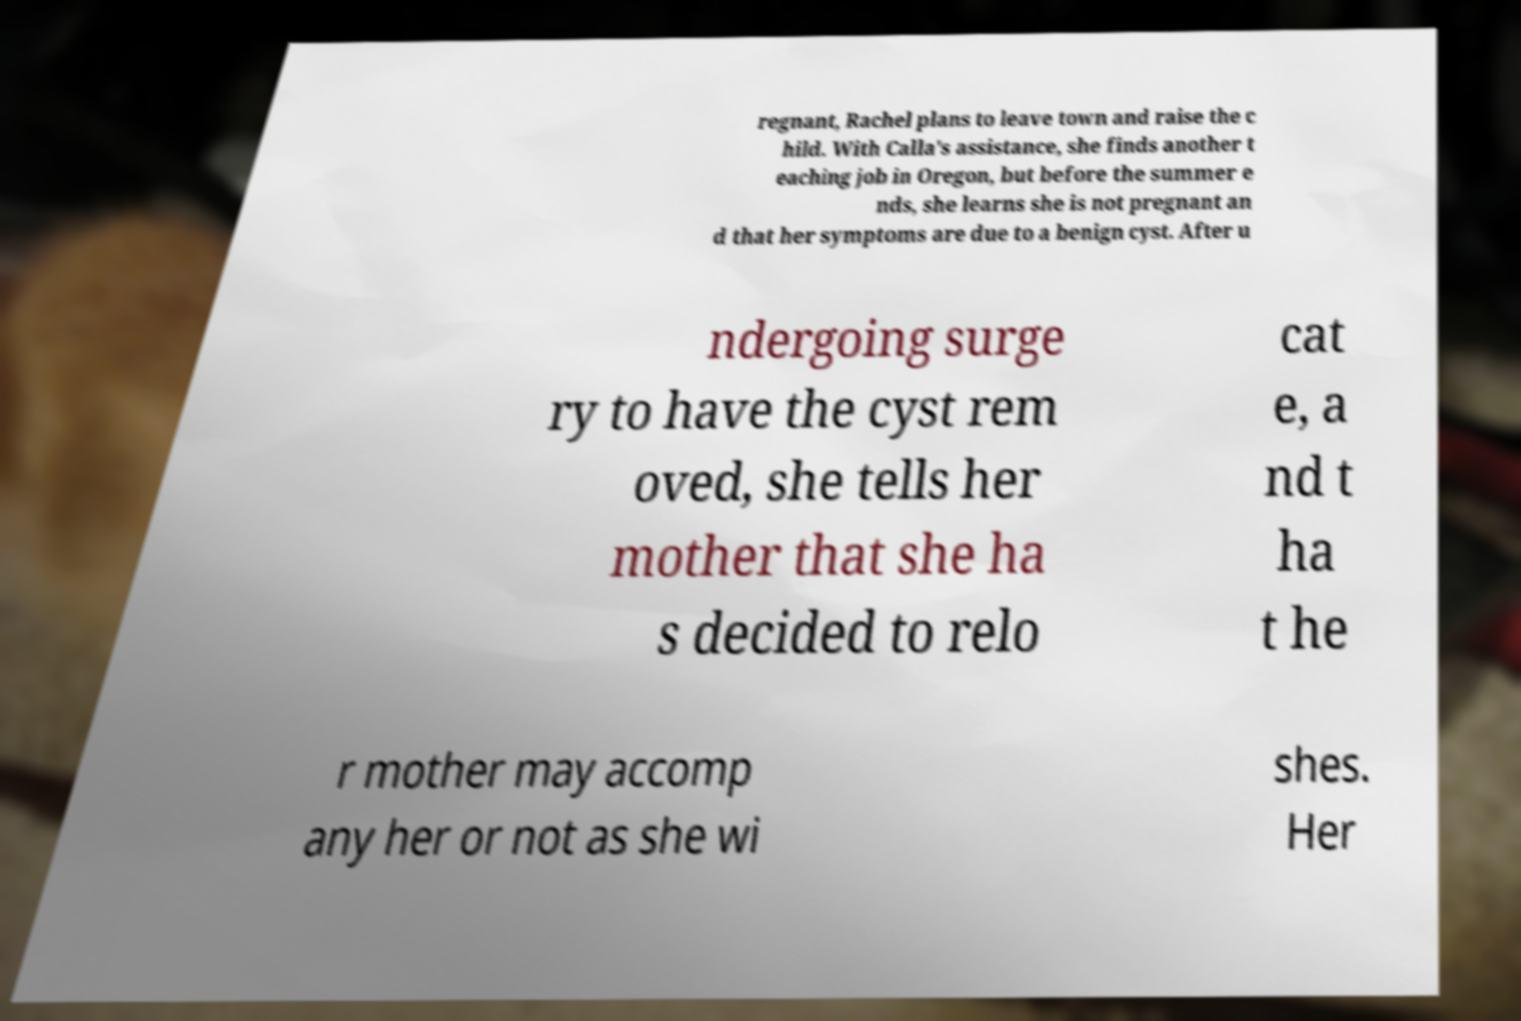For documentation purposes, I need the text within this image transcribed. Could you provide that? regnant, Rachel plans to leave town and raise the c hild. With Calla's assistance, she finds another t eaching job in Oregon, but before the summer e nds, she learns she is not pregnant an d that her symptoms are due to a benign cyst. After u ndergoing surge ry to have the cyst rem oved, she tells her mother that she ha s decided to relo cat e, a nd t ha t he r mother may accomp any her or not as she wi shes. Her 